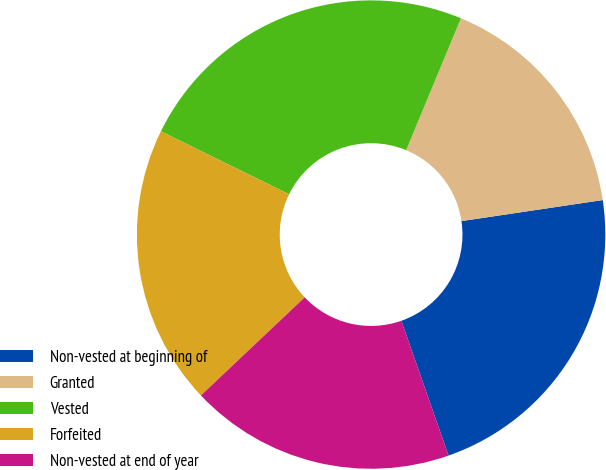Convert chart. <chart><loc_0><loc_0><loc_500><loc_500><pie_chart><fcel>Non-vested at beginning of<fcel>Granted<fcel>Vested<fcel>Forfeited<fcel>Non-vested at end of year<nl><fcel>21.99%<fcel>16.38%<fcel>24.0%<fcel>19.32%<fcel>18.31%<nl></chart> 